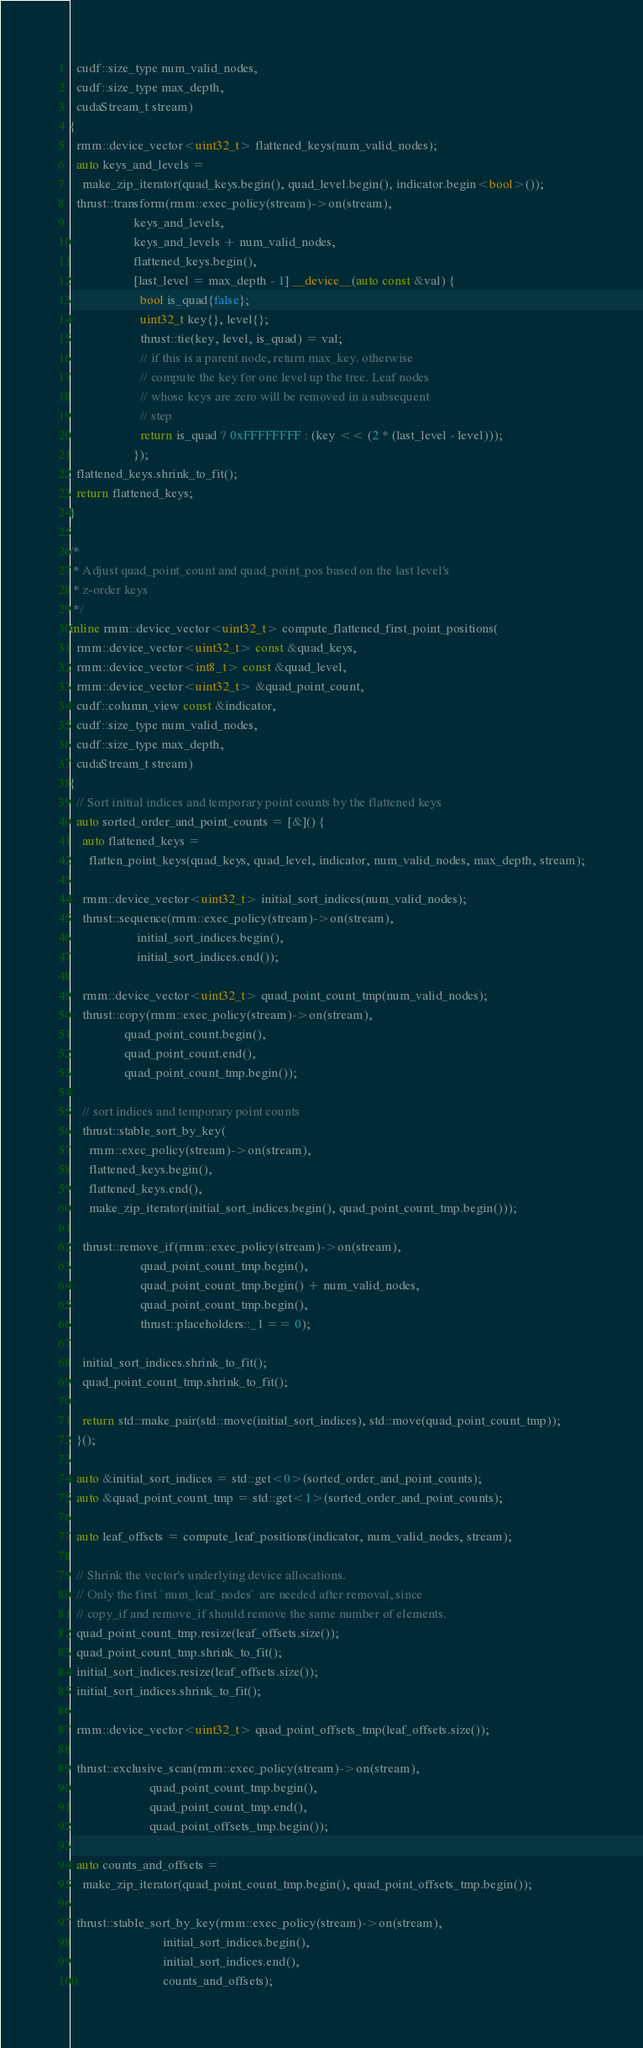Convert code to text. <code><loc_0><loc_0><loc_500><loc_500><_Cuda_>  cudf::size_type num_valid_nodes,
  cudf::size_type max_depth,
  cudaStream_t stream)
{
  rmm::device_vector<uint32_t> flattened_keys(num_valid_nodes);
  auto keys_and_levels =
    make_zip_iterator(quad_keys.begin(), quad_level.begin(), indicator.begin<bool>());
  thrust::transform(rmm::exec_policy(stream)->on(stream),
                    keys_and_levels,
                    keys_and_levels + num_valid_nodes,
                    flattened_keys.begin(),
                    [last_level = max_depth - 1] __device__(auto const &val) {
                      bool is_quad{false};
                      uint32_t key{}, level{};
                      thrust::tie(key, level, is_quad) = val;
                      // if this is a parent node, return max_key. otherwise
                      // compute the key for one level up the tree. Leaf nodes
                      // whose keys are zero will be removed in a subsequent
                      // step
                      return is_quad ? 0xFFFFFFFF : (key << (2 * (last_level - level)));
                    });
  flattened_keys.shrink_to_fit();
  return flattened_keys;
}

/*
 * Adjust quad_point_count and quad_point_pos based on the last level's
 * z-order keys
 */
inline rmm::device_vector<uint32_t> compute_flattened_first_point_positions(
  rmm::device_vector<uint32_t> const &quad_keys,
  rmm::device_vector<int8_t> const &quad_level,
  rmm::device_vector<uint32_t> &quad_point_count,
  cudf::column_view const &indicator,
  cudf::size_type num_valid_nodes,
  cudf::size_type max_depth,
  cudaStream_t stream)
{
  // Sort initial indices and temporary point counts by the flattened keys
  auto sorted_order_and_point_counts = [&]() {
    auto flattened_keys =
      flatten_point_keys(quad_keys, quad_level, indicator, num_valid_nodes, max_depth, stream);

    rmm::device_vector<uint32_t> initial_sort_indices(num_valid_nodes);
    thrust::sequence(rmm::exec_policy(stream)->on(stream),
                     initial_sort_indices.begin(),
                     initial_sort_indices.end());

    rmm::device_vector<uint32_t> quad_point_count_tmp(num_valid_nodes);
    thrust::copy(rmm::exec_policy(stream)->on(stream),
                 quad_point_count.begin(),
                 quad_point_count.end(),
                 quad_point_count_tmp.begin());

    // sort indices and temporary point counts
    thrust::stable_sort_by_key(
      rmm::exec_policy(stream)->on(stream),
      flattened_keys.begin(),
      flattened_keys.end(),
      make_zip_iterator(initial_sort_indices.begin(), quad_point_count_tmp.begin()));

    thrust::remove_if(rmm::exec_policy(stream)->on(stream),
                      quad_point_count_tmp.begin(),
                      quad_point_count_tmp.begin() + num_valid_nodes,
                      quad_point_count_tmp.begin(),
                      thrust::placeholders::_1 == 0);

    initial_sort_indices.shrink_to_fit();
    quad_point_count_tmp.shrink_to_fit();

    return std::make_pair(std::move(initial_sort_indices), std::move(quad_point_count_tmp));
  }();

  auto &initial_sort_indices = std::get<0>(sorted_order_and_point_counts);
  auto &quad_point_count_tmp = std::get<1>(sorted_order_and_point_counts);

  auto leaf_offsets = compute_leaf_positions(indicator, num_valid_nodes, stream);

  // Shrink the vector's underlying device allocations.
  // Only the first `num_leaf_nodes` are needed after removal, since
  // copy_if and remove_if should remove the same number of elements.
  quad_point_count_tmp.resize(leaf_offsets.size());
  quad_point_count_tmp.shrink_to_fit();
  initial_sort_indices.resize(leaf_offsets.size());
  initial_sort_indices.shrink_to_fit();

  rmm::device_vector<uint32_t> quad_point_offsets_tmp(leaf_offsets.size());

  thrust::exclusive_scan(rmm::exec_policy(stream)->on(stream),
                         quad_point_count_tmp.begin(),
                         quad_point_count_tmp.end(),
                         quad_point_offsets_tmp.begin());

  auto counts_and_offsets =
    make_zip_iterator(quad_point_count_tmp.begin(), quad_point_offsets_tmp.begin());

  thrust::stable_sort_by_key(rmm::exec_policy(stream)->on(stream),
                             initial_sort_indices.begin(),
                             initial_sort_indices.end(),
                             counts_and_offsets);
</code> 